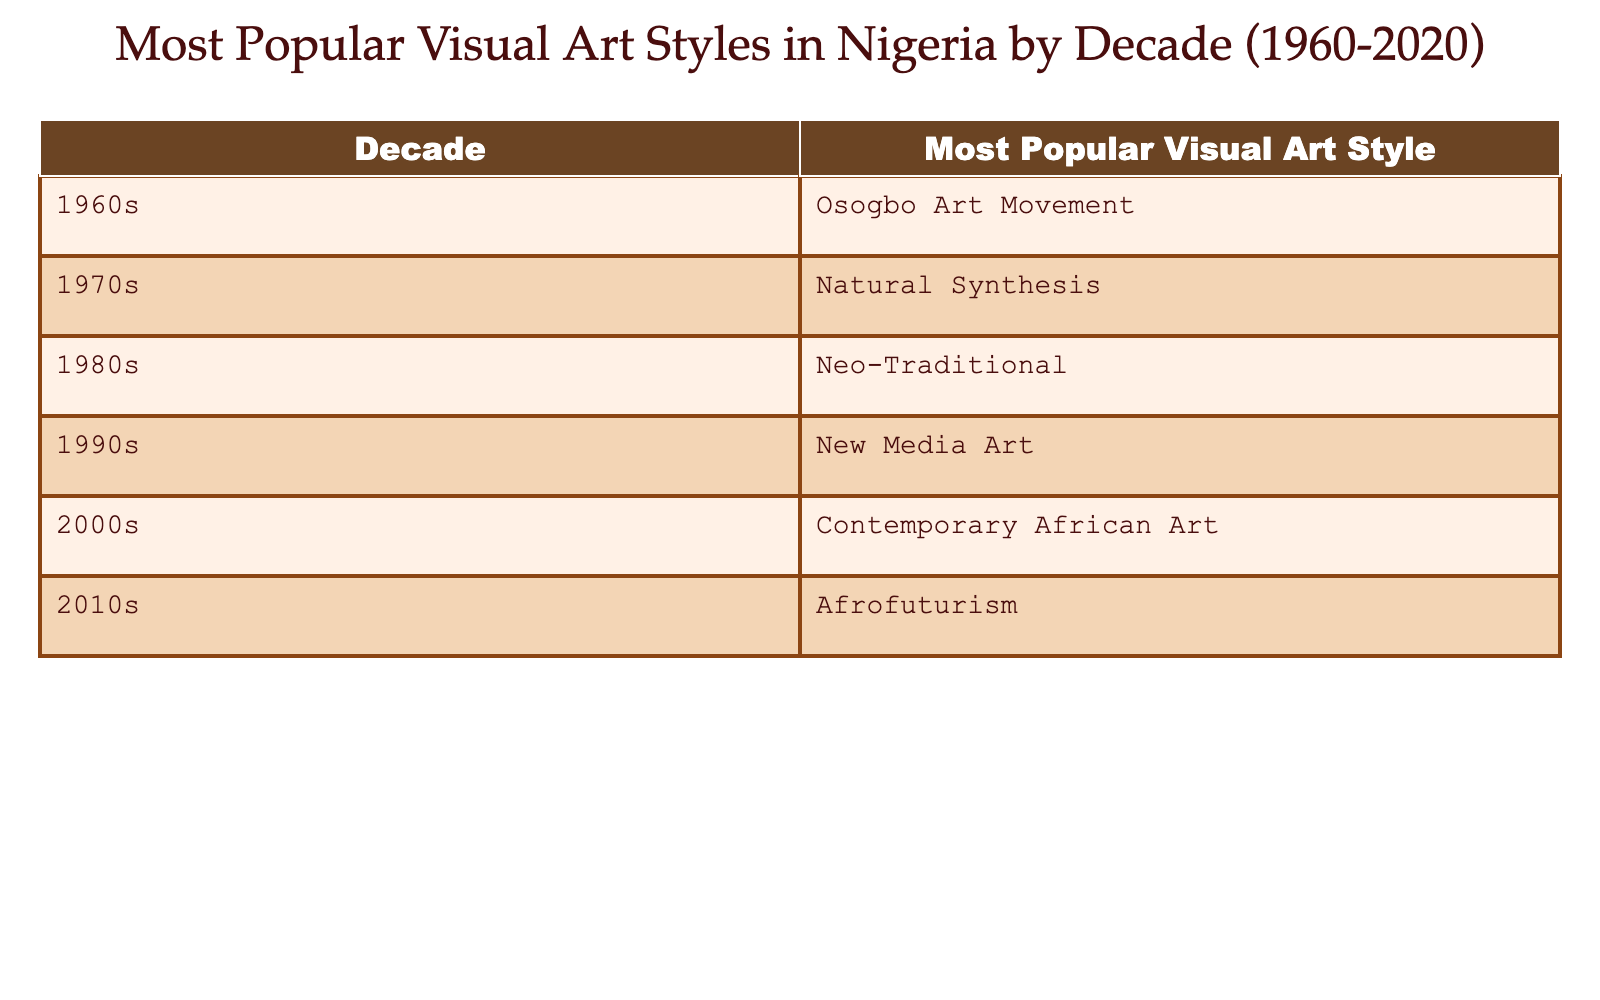What was the most popular visual art style in the 1980s in Nigeria? The table shows that the most popular visual art style in the 1980s was Neo-Traditional.
Answer: Neo-Traditional Which visual art style became popular in Nigeria during the 1990s? According to the table, the visual art style that became popular during the 1990s was New Media Art.
Answer: New Media Art In which decade did Afrofuturism gain popularity in Nigeria? The table indicates that Afrofuturism gained popularity in the 2010s.
Answer: 2010s What was the difference in the popular visual art style from the 1960s to the 2000s? From the 1960s to the 2000s, the art styles evolved from Osogbo Art Movement in the 1960s to Contemporary African Art in the 2000s, indicating a shift in artistic trends over four decades.
Answer: Shifted from Osogbo Art Movement to Contemporary African Art Is it true that Natural Synthesis was popular in the 1980s? The table confirms that Natural Synthesis was popular in the 1970s, not in the 1980s, so the statement is false.
Answer: False What was the trend of visual art styles in Nigeria from the 1960s to the 2010s? By analyzing the table, it appears that there is a trend of evolution where each decade introduced different and increasingly contemporary styles, moving from traditional roots to modern, future-oriented expressions like Afrofuturism.
Answer: Evolution from traditional to modern styles During which two decades were art styles that focus on contemporary themes popular? The table lists contemporary themes becoming popular in the 2000s with Contemporary African Art and in the 2010s with Afrofuturism, making these two decades the focus on contemporary themes.
Answer: 2000s and 2010s What is the average number of decades represented in terms of different visual art styles listed? There are six distinct decades in the table, each showing a different art style, thus the average number of decades represented in terms of different styles is six.
Answer: 6 